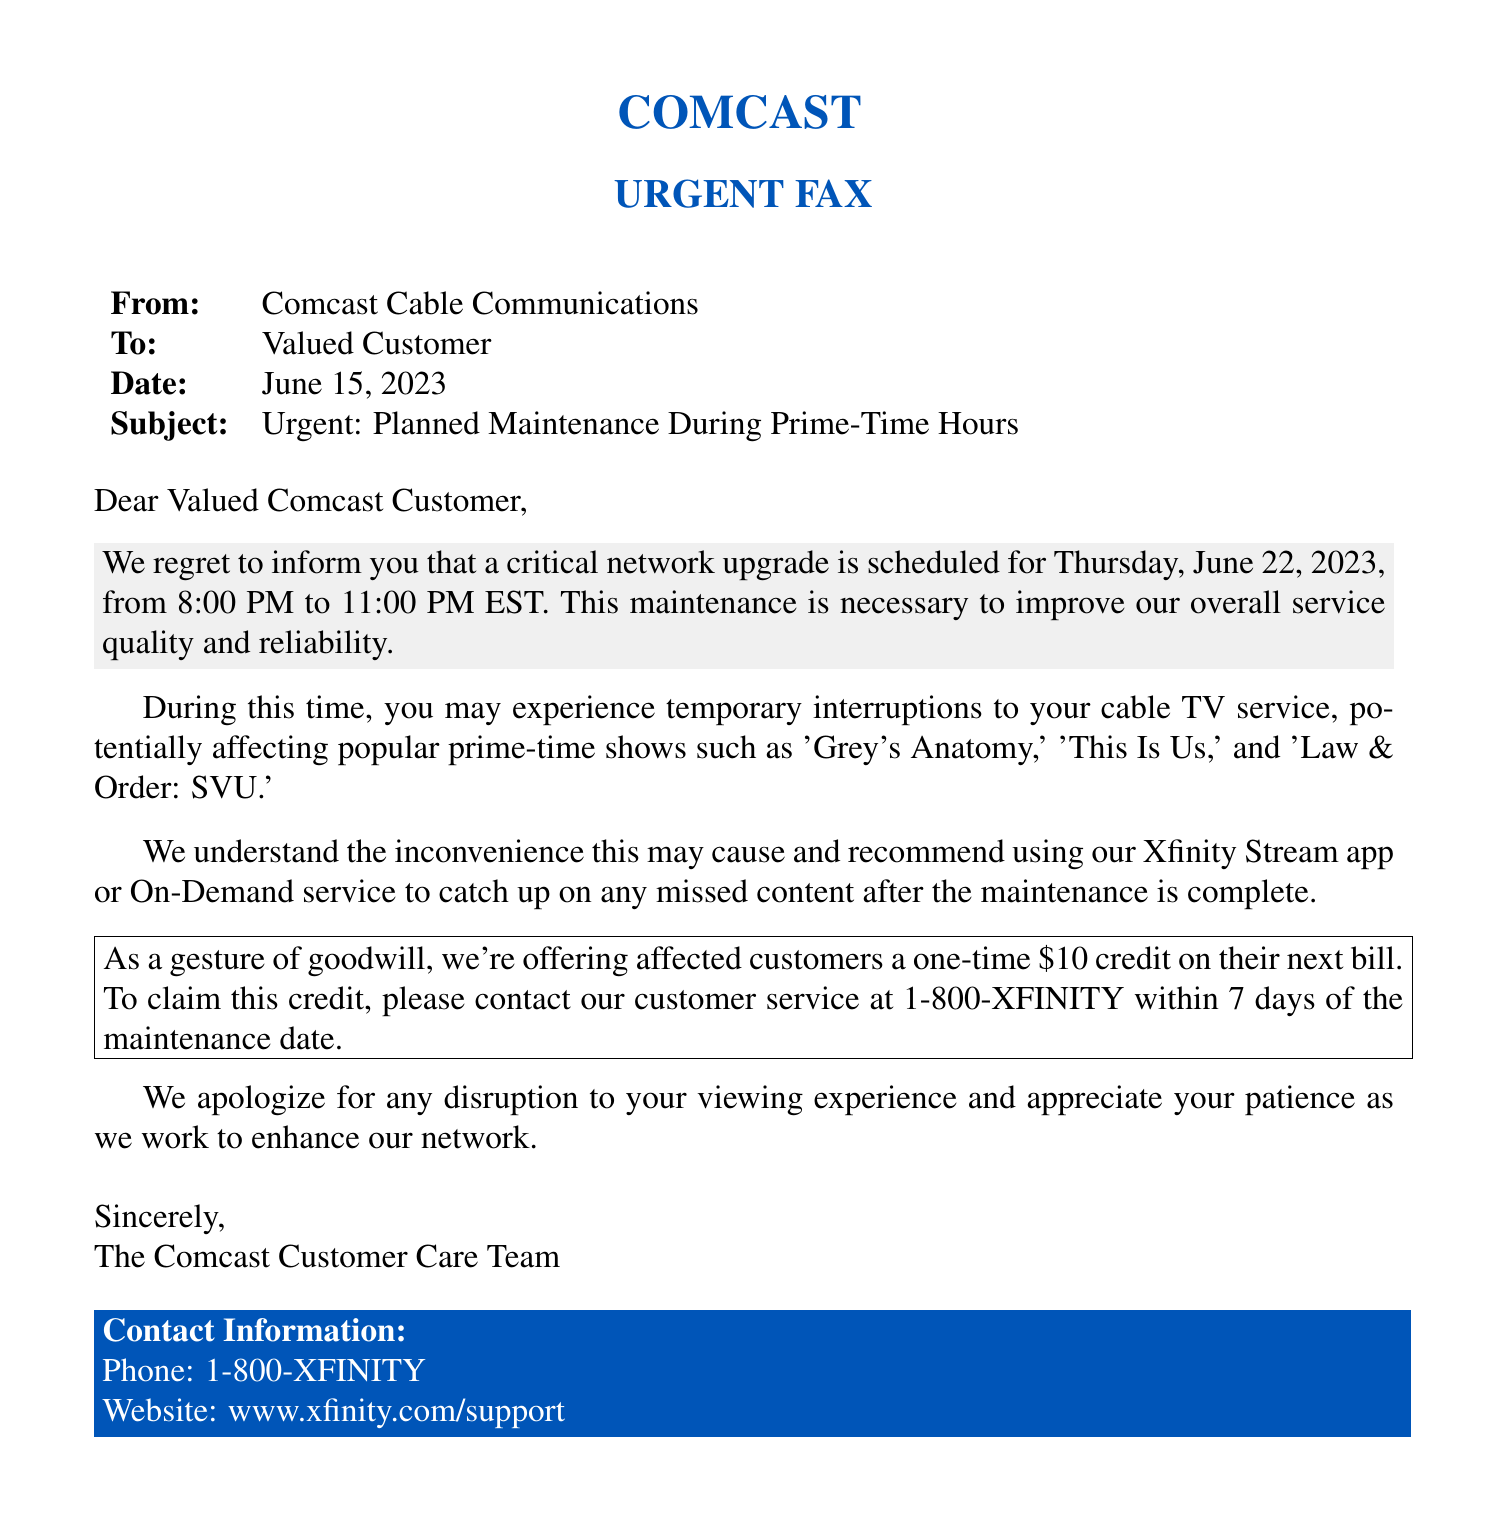What is the date of the scheduled maintenance? The document specifies that the scheduled maintenance will take place on June 22, 2023.
Answer: June 22, 2023 What time will the maintenance begin? The fax indicates that the maintenance will start at 8:00 PM EST.
Answer: 8:00 PM What is the duration of the planned maintenance? The document states that the maintenance will last for three hours, from 8:00 PM to 11:00 PM.
Answer: Three hours Which popular TV shows may be affected during the maintenance? The document lists 'Grey's Anatomy,' 'This Is Us,' and 'Law & Order: SVU' as possibly affected.
Answer: 'Grey's Anatomy,' 'This Is Us,' 'Law & Order: SVU' What credit is offered to affected customers? The fax mentions a one-time $10 credit as a goodwill gesture to affected customers.
Answer: $10 How can customers claim the offered credit? The document advises customers to contact customer service within 7 days to claim the credit.
Answer: Contact customer service What is the purpose of the maintenance? The fax states that the maintenance is necessary to improve overall service quality and reliability.
Answer: Improve service quality and reliability What is the customer service phone number provided? The document provides the customer service phone number as 1-800-XFINITY.
Answer: 1-800-XFINITY 